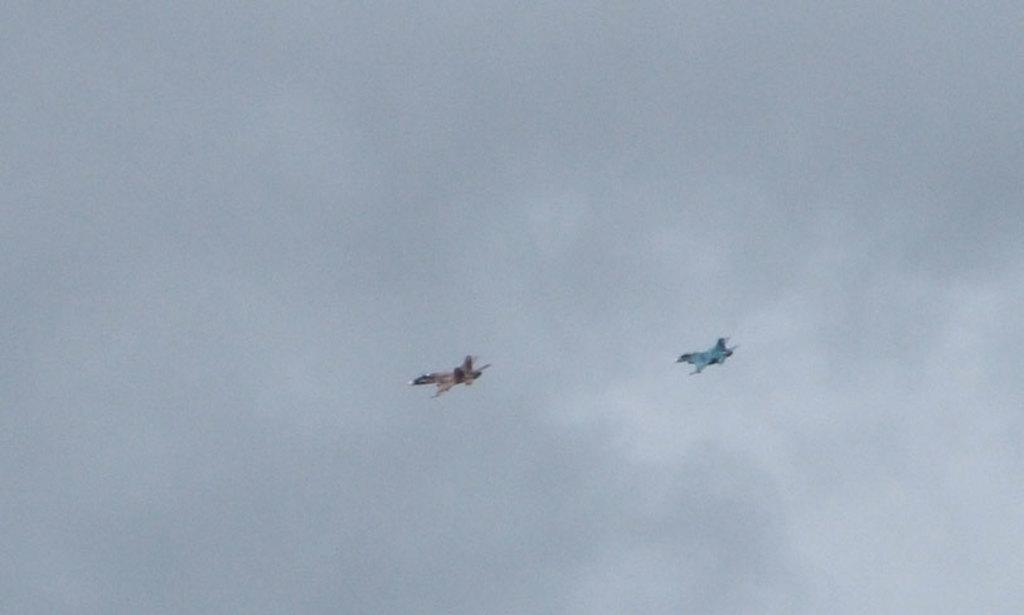What is the main subject of the image? The main subject of the image is two aircraft. Can you describe the background of the image? The sky is visible in the background of the image. Is there a volcano visible on the ground in the image? There is no ground or volcano present in the image; it features two aircraft and a sky background. 